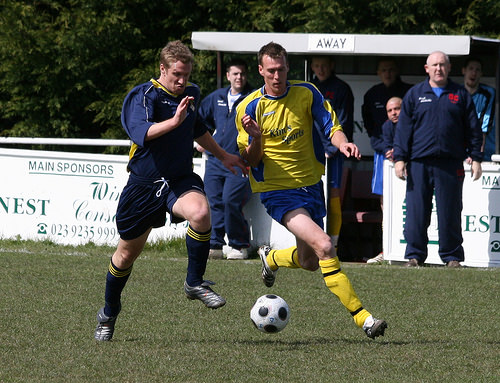<image>
Is the ball on the grass? No. The ball is not positioned on the grass. They may be near each other, but the ball is not supported by or resting on top of the grass. Where is the ball in relation to the man? Is it in front of the man? Yes. The ball is positioned in front of the man, appearing closer to the camera viewpoint. 